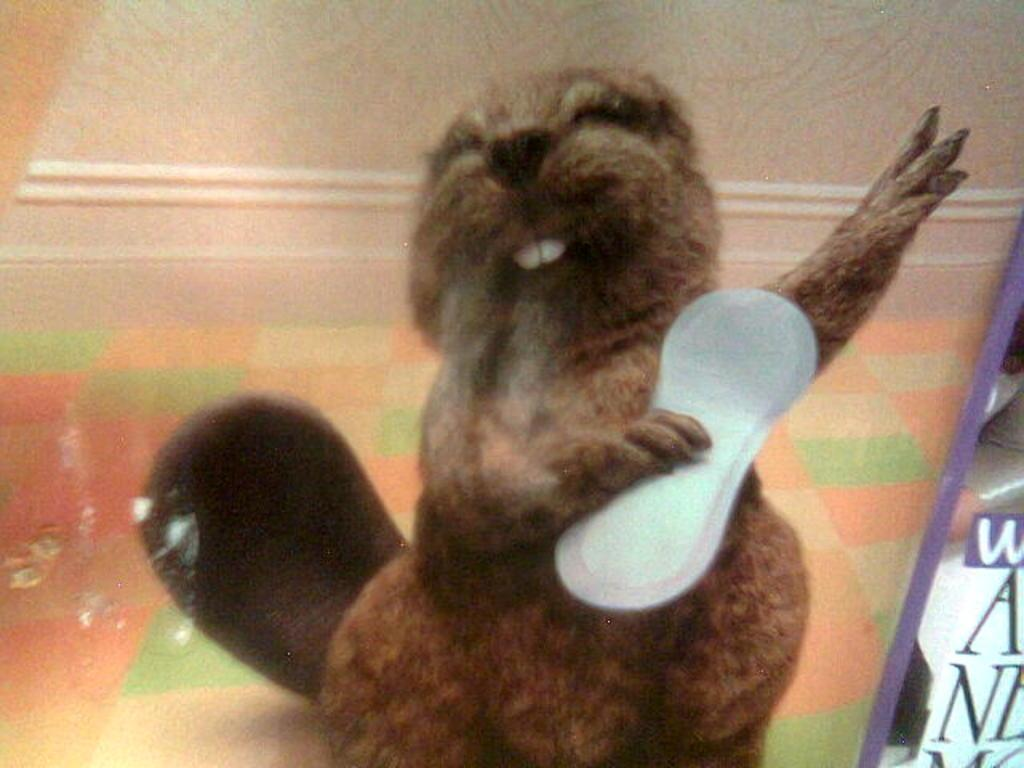What type of animal is in the image? There is a mammal in the image. What is the mammal doing in the image? The mammal is holding an object. What color is the object the mammal is holding? The object is white in color. Where can text be found in the image? Text is visible on the right side of the image. How many bats are flying around the mammal in the image? There are no bats present in the image. What type of soap is the mammal using to clean the object? There is no soap present in the image, and the mammal is not cleaning the object. 